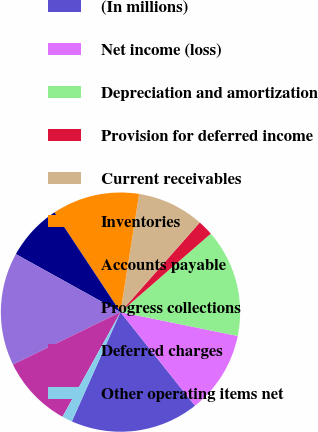<chart> <loc_0><loc_0><loc_500><loc_500><pie_chart><fcel>(In millions)<fcel>Net income (loss)<fcel>Depreciation and amortization<fcel>Provision for deferred income<fcel>Current receivables<fcel>Inventories<fcel>Accounts payable<fcel>Progress collections<fcel>Deferred charges<fcel>Other operating items net<nl><fcel>17.36%<fcel>11.11%<fcel>14.58%<fcel>2.09%<fcel>9.03%<fcel>11.8%<fcel>7.64%<fcel>15.28%<fcel>9.72%<fcel>1.39%<nl></chart> 